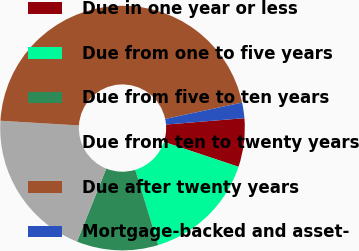Convert chart. <chart><loc_0><loc_0><loc_500><loc_500><pie_chart><fcel>Due in one year or less<fcel>Due from one to five years<fcel>Due from five to ten years<fcel>Due from ten to twenty years<fcel>Due after twenty years<fcel>Mortgage-backed and asset-<nl><fcel>6.42%<fcel>15.15%<fcel>10.78%<fcel>19.89%<fcel>45.71%<fcel>2.05%<nl></chart> 